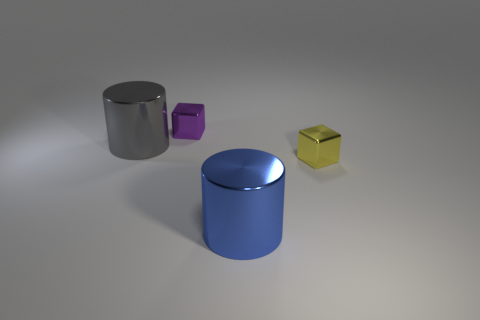Add 3 tiny purple metallic things. How many objects exist? 7 Subtract 0 brown balls. How many objects are left? 4 Subtract all large gray matte cylinders. Subtract all gray things. How many objects are left? 3 Add 4 blue shiny things. How many blue shiny things are left? 5 Add 2 small shiny blocks. How many small shiny blocks exist? 4 